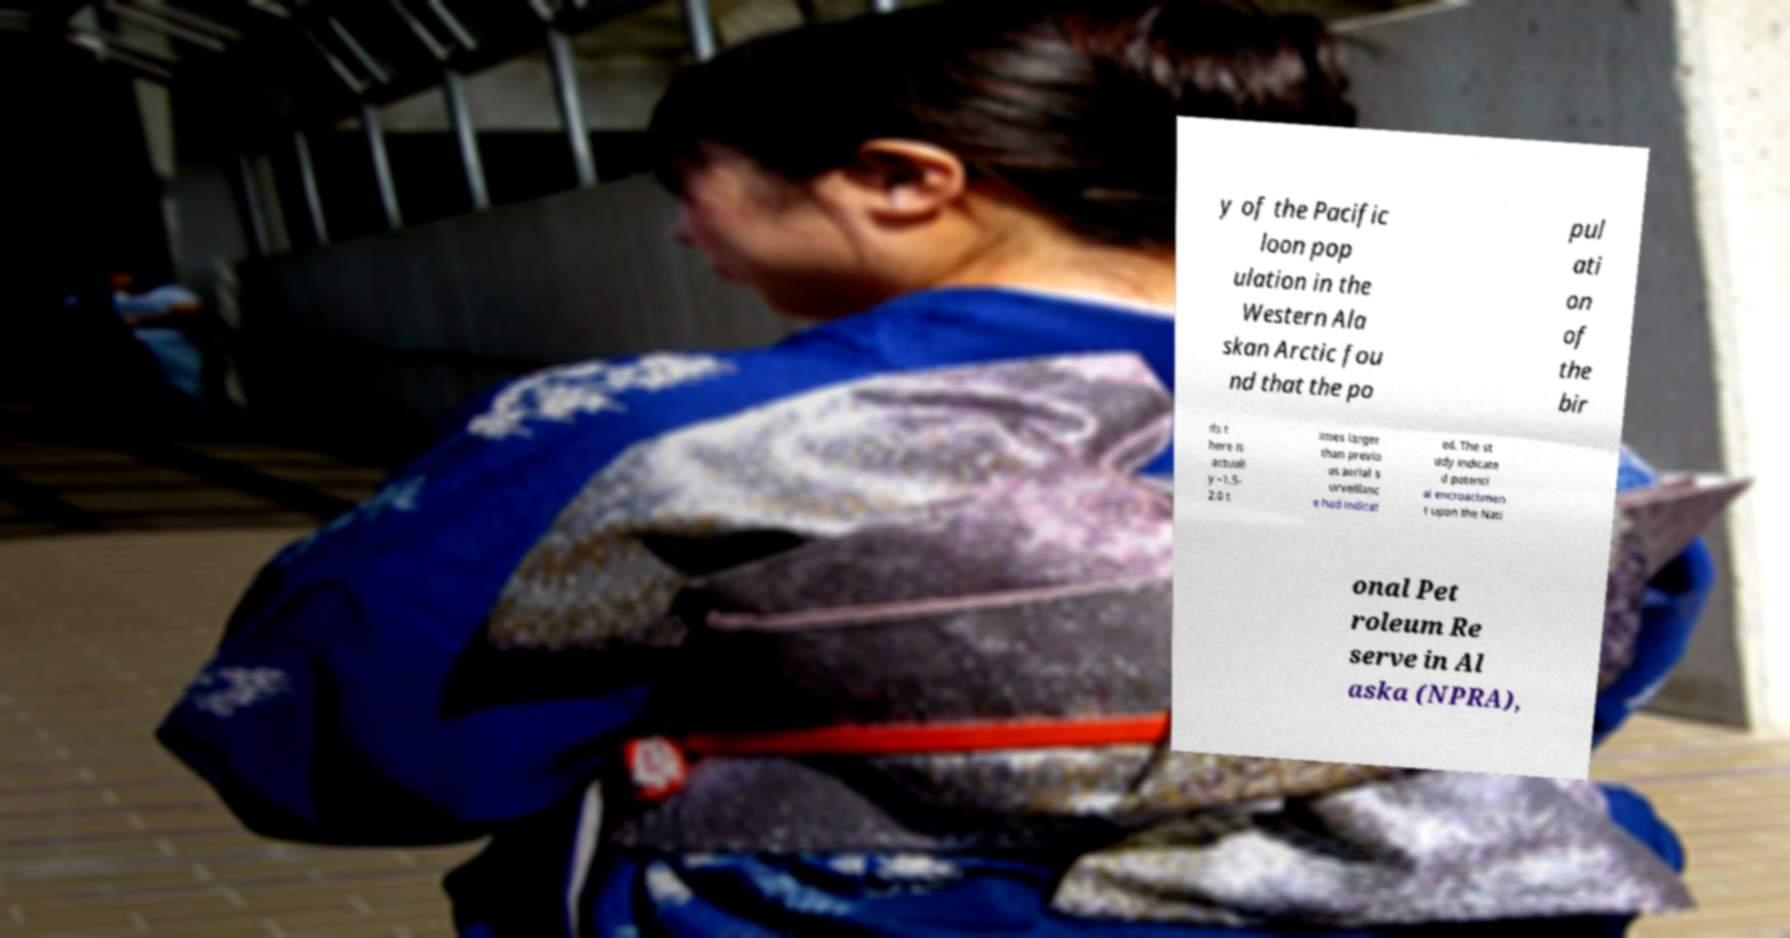Can you read and provide the text displayed in the image?This photo seems to have some interesting text. Can you extract and type it out for me? y of the Pacific loon pop ulation in the Western Ala skan Arctic fou nd that the po pul ati on of the bir ds t here is actuall y ~1.5- 2.0 t imes larger than previo us aerial s urveillanc e had indicat ed. The st udy indicate d potenti al encroachmen t upon the Nati onal Pet roleum Re serve in Al aska (NPRA), 